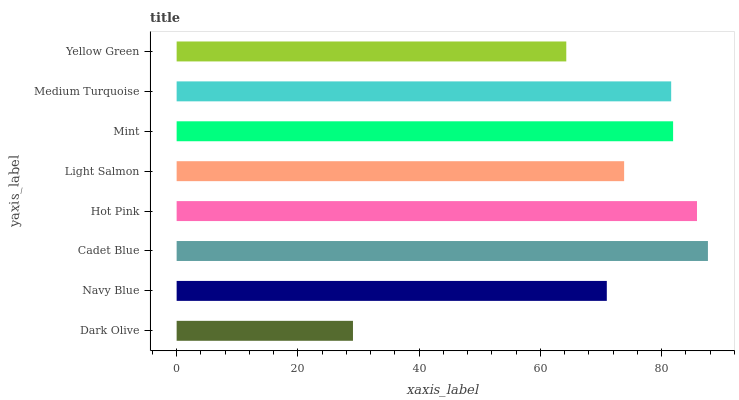Is Dark Olive the minimum?
Answer yes or no. Yes. Is Cadet Blue the maximum?
Answer yes or no. Yes. Is Navy Blue the minimum?
Answer yes or no. No. Is Navy Blue the maximum?
Answer yes or no. No. Is Navy Blue greater than Dark Olive?
Answer yes or no. Yes. Is Dark Olive less than Navy Blue?
Answer yes or no. Yes. Is Dark Olive greater than Navy Blue?
Answer yes or no. No. Is Navy Blue less than Dark Olive?
Answer yes or no. No. Is Medium Turquoise the high median?
Answer yes or no. Yes. Is Light Salmon the low median?
Answer yes or no. Yes. Is Dark Olive the high median?
Answer yes or no. No. Is Navy Blue the low median?
Answer yes or no. No. 